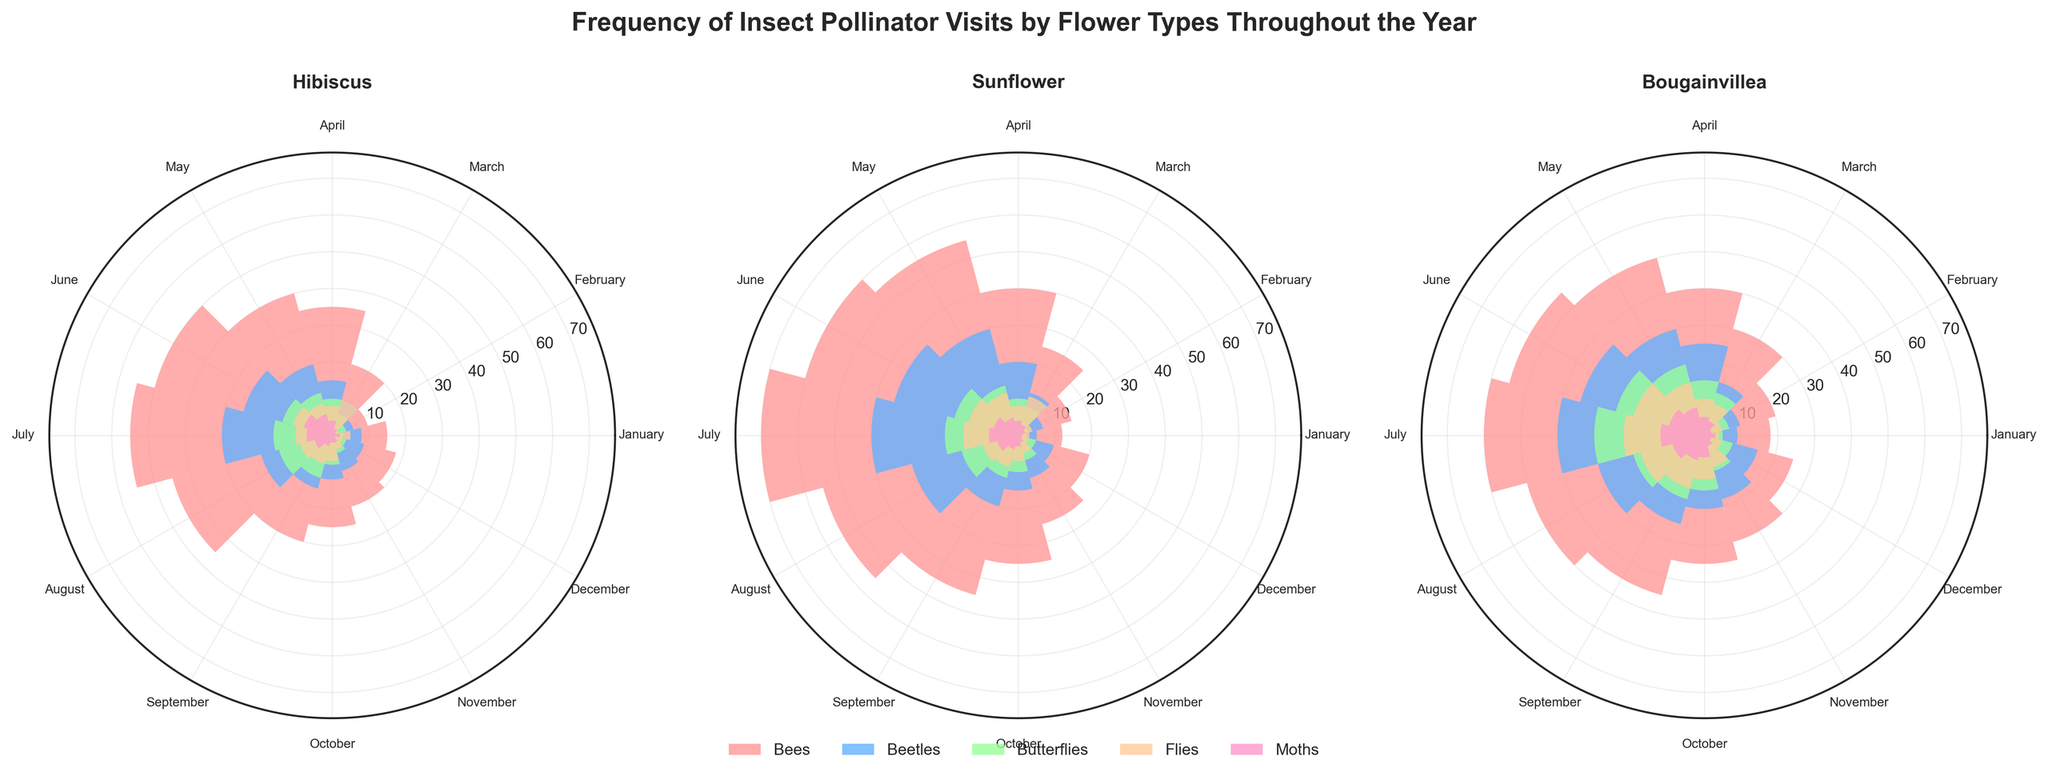What is the title of the figure? The title of the figure is located at the top and is prominently displayed with a larger font size.
Answer: Frequency of Insect Pollinator Visits by Flower Types Throughout the Year Which flower type has the highest number of bee visits in June? By looking at the June segment for each flower type, find the flower with the tallest bar representing bee visits.
Answer: Sunflower How does the number of butterfly visits to Bougainvillea in July compare to June? Identify the height of the bars representing butterfly visits in both June and July for Bougainvillea. Compare the two values numerically.
Answer: July has 5 more visits than June In which month does the Hibiscus have the least visits from flies? Check the height of the bars representing fly visits for Hibiscus across all months and find the shortest one.
Answer: December What is the average number of beetle visits to Sunflower in the first three months? Sum the beetle visits for January, February, and March for Sunflower and divide by 3. Calculation: (5 + 7 + 12) / 3.
Answer: 8 Which insect pollinator had the least visits across all flower types in October? For each flower type in October, observe the smallest bar's height among the pollinator types and compare them.
Answer: Moths Compare the number of bee visits to Hibiscus and Bougainvillea in May. Which is higher? Look at the height of the bars representing bee visits in May for both Hibiscus and Bougainvillea.
Answer: Bougainvillea How does the total number of insect visits to Sunflower in August compare to May? Sum the visit numbers for all pollinator types in both months for Sunflower and compare the totals.
Answer: August is less than May Which month shows the peak number of moth visits to Bougainvillea? Scan the monthly segments for Bougainvillea to find the tallest bar representing moth visits.
Answer: July 